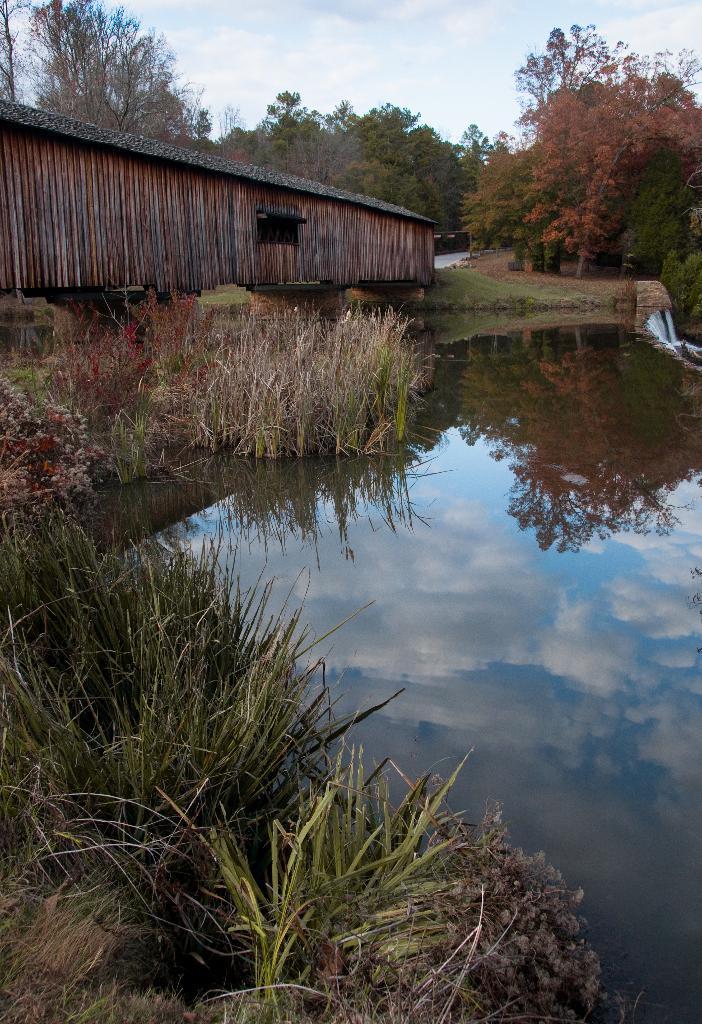Describe this image in one or two sentences. In the foreground we can see the grass. Here we can see the water on the right side. Here we can see a wooden shed on the top left side. In the background, we can see the trees. This is a sky with clouds. 